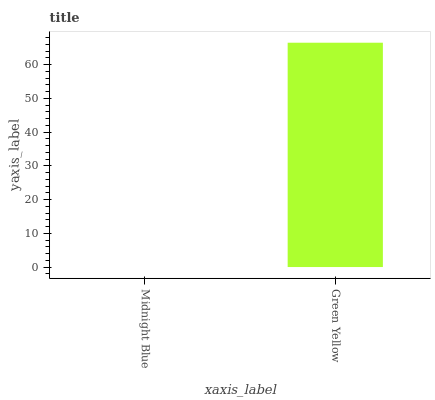Is Midnight Blue the minimum?
Answer yes or no. Yes. Is Green Yellow the maximum?
Answer yes or no. Yes. Is Green Yellow the minimum?
Answer yes or no. No. Is Green Yellow greater than Midnight Blue?
Answer yes or no. Yes. Is Midnight Blue less than Green Yellow?
Answer yes or no. Yes. Is Midnight Blue greater than Green Yellow?
Answer yes or no. No. Is Green Yellow less than Midnight Blue?
Answer yes or no. No. Is Green Yellow the high median?
Answer yes or no. Yes. Is Midnight Blue the low median?
Answer yes or no. Yes. Is Midnight Blue the high median?
Answer yes or no. No. Is Green Yellow the low median?
Answer yes or no. No. 